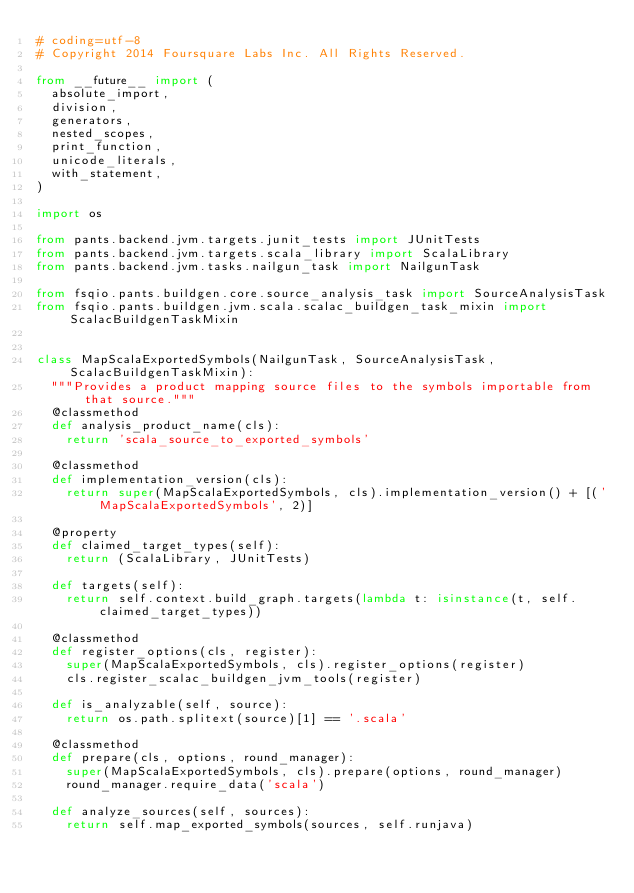Convert code to text. <code><loc_0><loc_0><loc_500><loc_500><_Python_># coding=utf-8
# Copyright 2014 Foursquare Labs Inc. All Rights Reserved.

from __future__ import (
  absolute_import,
  division,
  generators,
  nested_scopes,
  print_function,
  unicode_literals,
  with_statement,
)

import os

from pants.backend.jvm.targets.junit_tests import JUnitTests
from pants.backend.jvm.targets.scala_library import ScalaLibrary
from pants.backend.jvm.tasks.nailgun_task import NailgunTask

from fsqio.pants.buildgen.core.source_analysis_task import SourceAnalysisTask
from fsqio.pants.buildgen.jvm.scala.scalac_buildgen_task_mixin import ScalacBuildgenTaskMixin


class MapScalaExportedSymbols(NailgunTask, SourceAnalysisTask, ScalacBuildgenTaskMixin):
  """Provides a product mapping source files to the symbols importable from that source."""
  @classmethod
  def analysis_product_name(cls):
    return 'scala_source_to_exported_symbols'

  @classmethod
  def implementation_version(cls):
    return super(MapScalaExportedSymbols, cls).implementation_version() + [('MapScalaExportedSymbols', 2)]

  @property
  def claimed_target_types(self):
    return (ScalaLibrary, JUnitTests)

  def targets(self):
    return self.context.build_graph.targets(lambda t: isinstance(t, self.claimed_target_types))

  @classmethod
  def register_options(cls, register):
    super(MapScalaExportedSymbols, cls).register_options(register)
    cls.register_scalac_buildgen_jvm_tools(register)

  def is_analyzable(self, source):
    return os.path.splitext(source)[1] == '.scala'

  @classmethod
  def prepare(cls, options, round_manager):
    super(MapScalaExportedSymbols, cls).prepare(options, round_manager)
    round_manager.require_data('scala')

  def analyze_sources(self, sources):
    return self.map_exported_symbols(sources, self.runjava)
</code> 